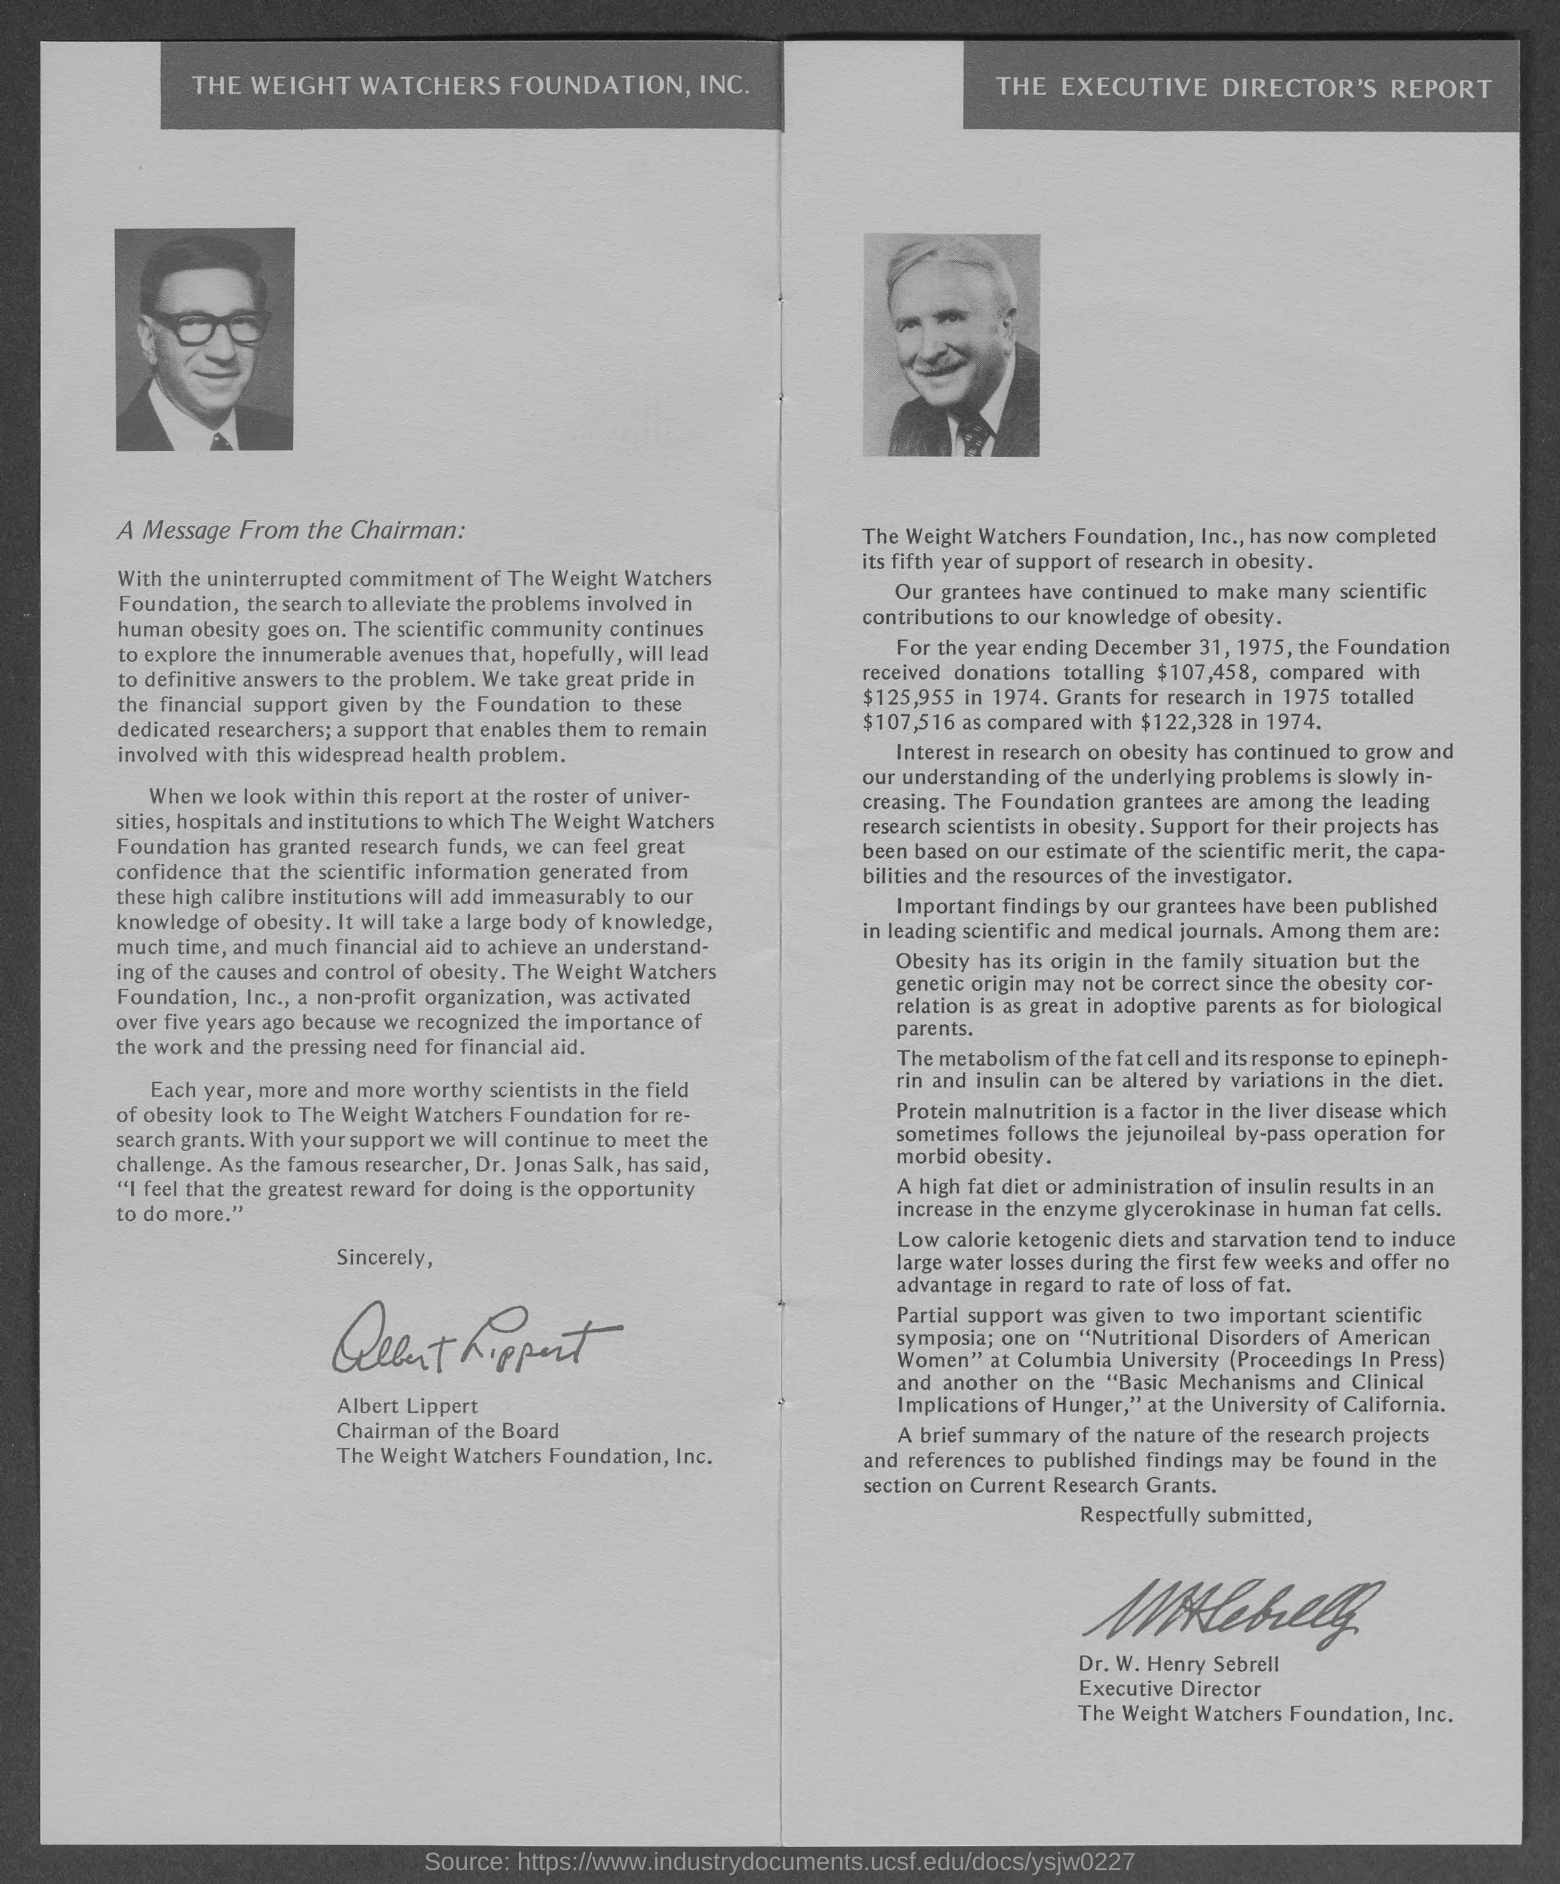Whose photograph is shown on the left side of the document?
Offer a very short reply. Albert Lippert. Whose photograph is shown on the right side of the document?
Offer a very short reply. Executive Director. Who is the Chairman?
Your answer should be compact. Albert Lippert. Who is the Executive Director?
Your answer should be compact. Dr. W. Henry Sebrell. How many donations has received the Foundation for the year ending December 31, 1975?
Keep it short and to the point. $ 107,458. What is the Currency?
Ensure brevity in your answer.  $. 